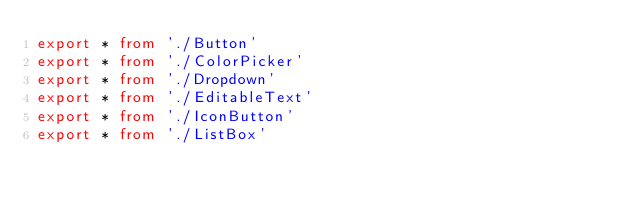Convert code to text. <code><loc_0><loc_0><loc_500><loc_500><_TypeScript_>export * from './Button'
export * from './ColorPicker'
export * from './Dropdown'
export * from './EditableText'
export * from './IconButton'
export * from './ListBox'</code> 